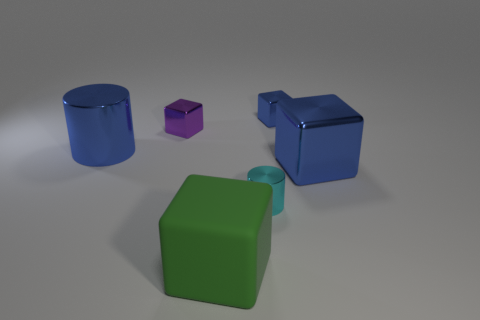Is there anything else that is the same material as the large green thing?
Your response must be concise. No. Are there any big green matte objects that are on the left side of the tiny purple thing that is behind the cyan thing?
Your response must be concise. No. There is another tiny thing that is the same shape as the small blue thing; what is it made of?
Provide a succinct answer. Metal. Is the number of blue metal cubes behind the big blue metal cylinder greater than the number of matte things on the left side of the cyan metal cylinder?
Ensure brevity in your answer.  No. There is a tiny cyan object that is made of the same material as the big blue cylinder; what shape is it?
Provide a short and direct response. Cylinder. Is the number of small objects to the left of the small cylinder greater than the number of matte spheres?
Provide a short and direct response. Yes. How many other tiny cylinders are the same color as the tiny metal cylinder?
Give a very brief answer. 0. How many other things are there of the same color as the large cylinder?
Ensure brevity in your answer.  2. Is the number of purple blocks greater than the number of big blue things?
Offer a very short reply. No. What is the big blue cylinder made of?
Your answer should be compact. Metal. 